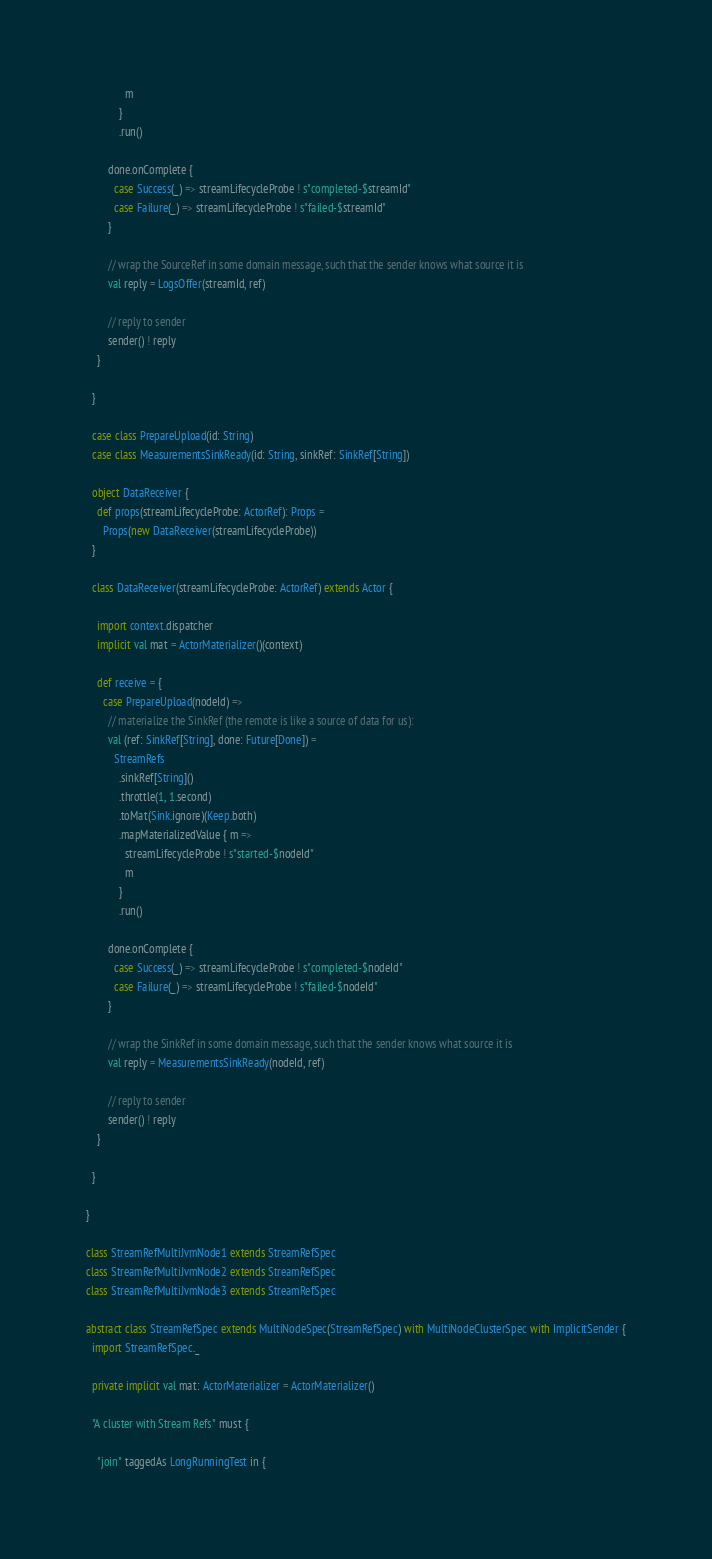<code> <loc_0><loc_0><loc_500><loc_500><_Scala_>              m
            }
            .run()

        done.onComplete {
          case Success(_) => streamLifecycleProbe ! s"completed-$streamId"
          case Failure(_) => streamLifecycleProbe ! s"failed-$streamId"
        }

        // wrap the SourceRef in some domain message, such that the sender knows what source it is
        val reply = LogsOffer(streamId, ref)

        // reply to sender
        sender() ! reply
    }

  }

  case class PrepareUpload(id: String)
  case class MeasurementsSinkReady(id: String, sinkRef: SinkRef[String])

  object DataReceiver {
    def props(streamLifecycleProbe: ActorRef): Props =
      Props(new DataReceiver(streamLifecycleProbe))
  }

  class DataReceiver(streamLifecycleProbe: ActorRef) extends Actor {

    import context.dispatcher
    implicit val mat = ActorMaterializer()(context)

    def receive = {
      case PrepareUpload(nodeId) =>
        // materialize the SinkRef (the remote is like a source of data for us):
        val (ref: SinkRef[String], done: Future[Done]) =
          StreamRefs
            .sinkRef[String]()
            .throttle(1, 1.second)
            .toMat(Sink.ignore)(Keep.both)
            .mapMaterializedValue { m =>
              streamLifecycleProbe ! s"started-$nodeId"
              m
            }
            .run()

        done.onComplete {
          case Success(_) => streamLifecycleProbe ! s"completed-$nodeId"
          case Failure(_) => streamLifecycleProbe ! s"failed-$nodeId"
        }

        // wrap the SinkRef in some domain message, such that the sender knows what source it is
        val reply = MeasurementsSinkReady(nodeId, ref)

        // reply to sender
        sender() ! reply
    }

  }

}

class StreamRefMultiJvmNode1 extends StreamRefSpec
class StreamRefMultiJvmNode2 extends StreamRefSpec
class StreamRefMultiJvmNode3 extends StreamRefSpec

abstract class StreamRefSpec extends MultiNodeSpec(StreamRefSpec) with MultiNodeClusterSpec with ImplicitSender {
  import StreamRefSpec._

  private implicit val mat: ActorMaterializer = ActorMaterializer()

  "A cluster with Stream Refs" must {

    "join" taggedAs LongRunningTest in {</code> 